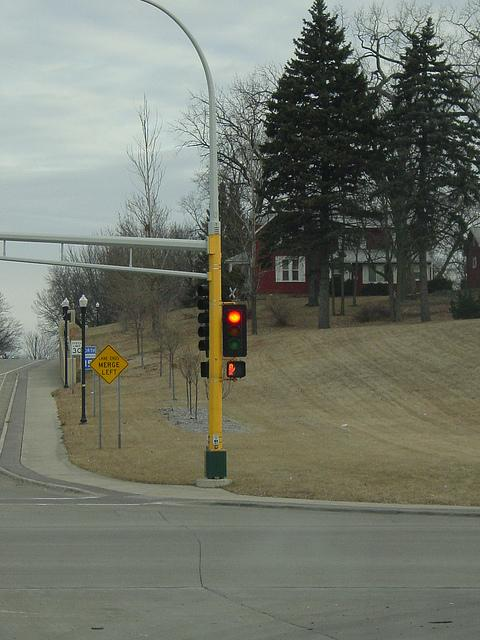Where is the house located? hill 